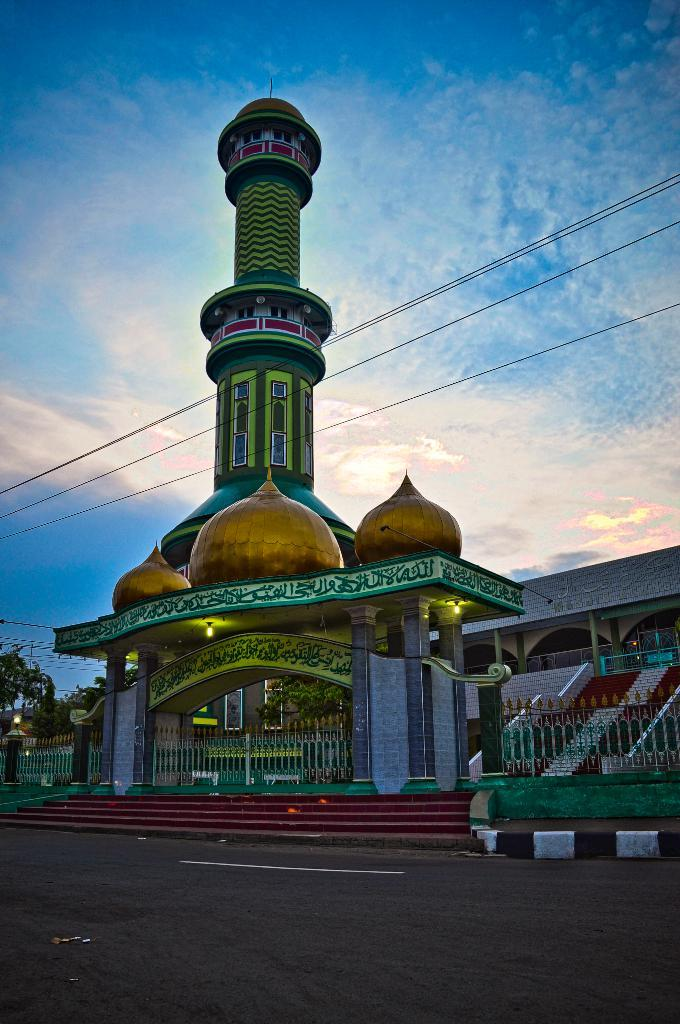What type of structure is present in the image? There is a building in the image. What features can be observed on the building? The building has windows, a gate, stairs, lights, and a fence. What else is visible in the image besides the building? There is a road, wires, trees, and the sky visible in the image. How would you describe the sky in the image? The sky appears cloudy in the image. Where is the honey located in the image? There is no honey present in the image. What type of club can be seen in the image? There is no club present in the image. 